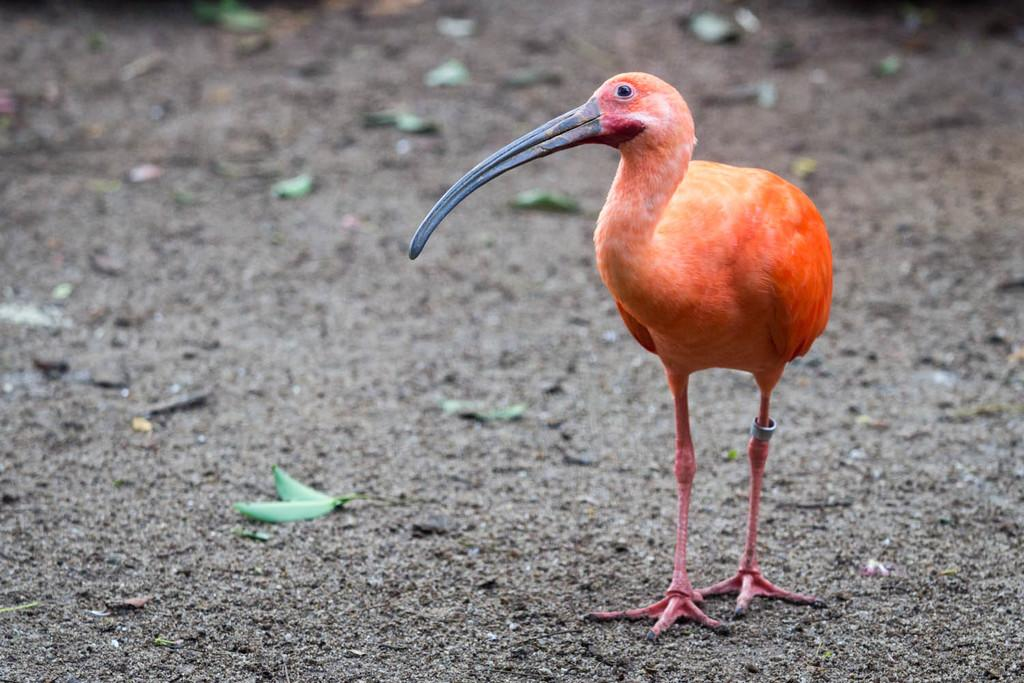What type of animal can be seen in the picture? There is a bird in the picture. What can be found on the ground in the picture? There are leaves on the ground in the picture. What is the plot of the bird's story in the picture? There is no plot or story depicted in the picture; it simply shows a bird and leaves on the ground. How does the bird express laughter in the picture? The bird does not express laughter in the picture, as it is a still image and not a living, expressive being. 